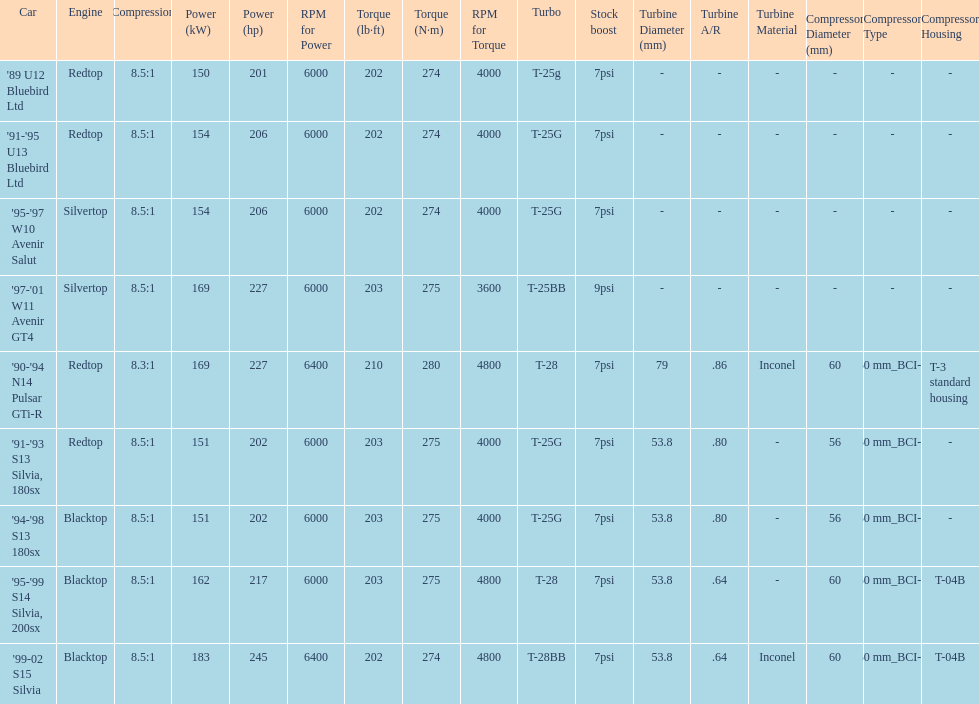How many models used the redtop engine? 4. 